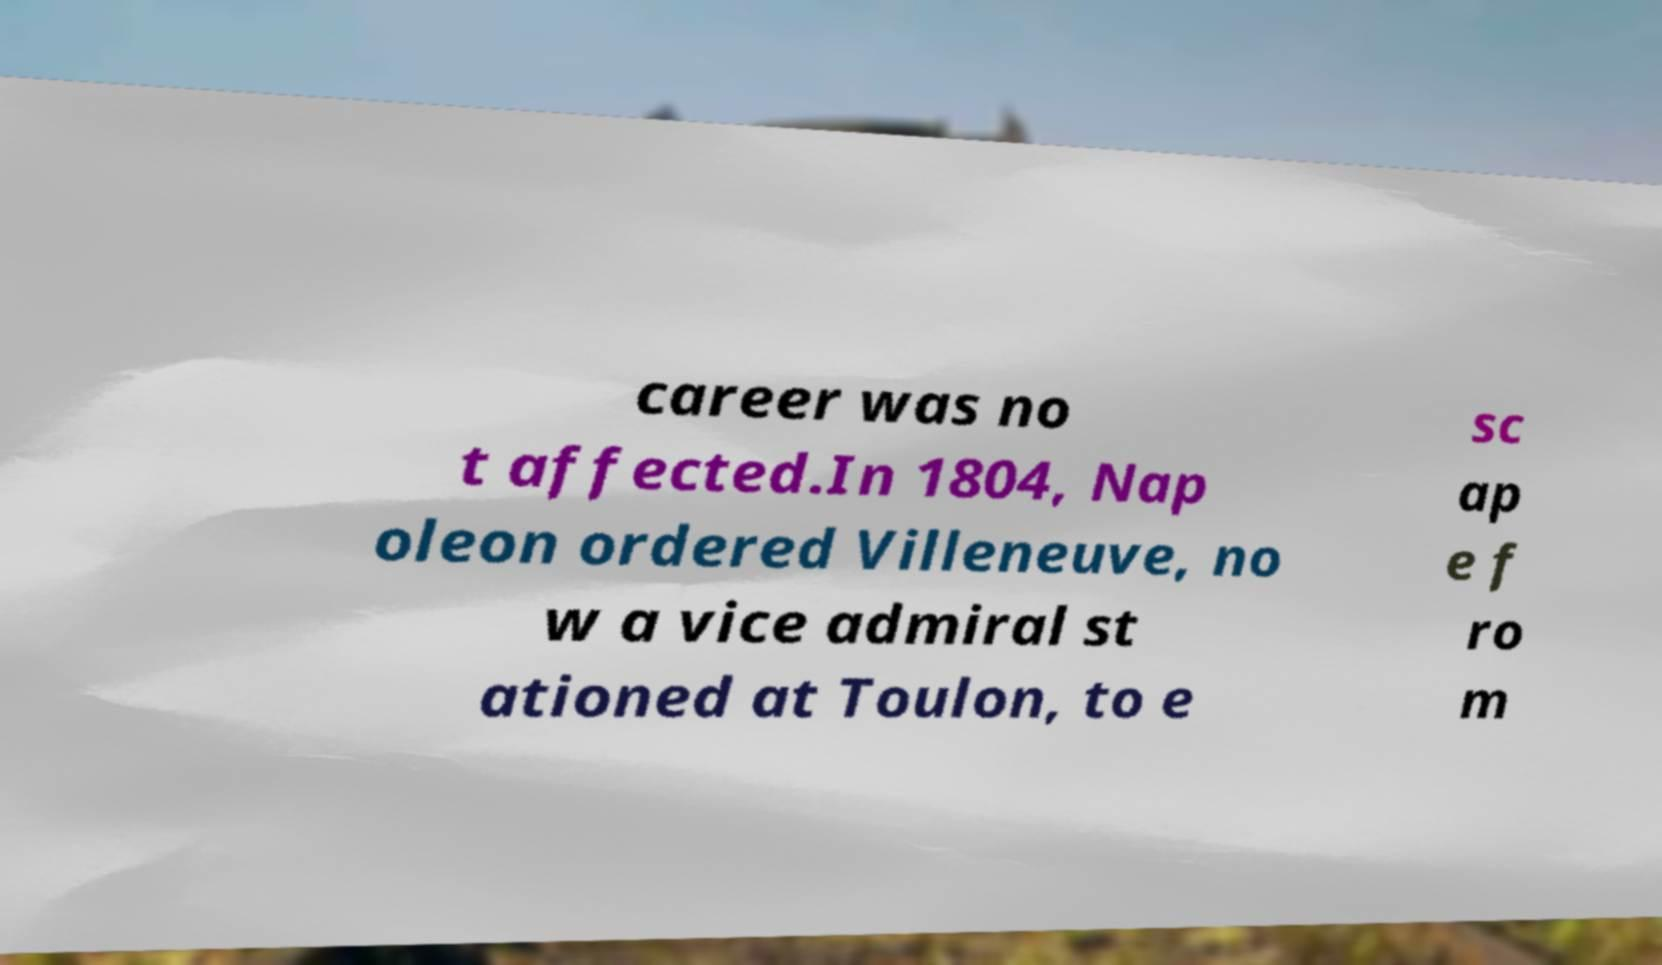What messages or text are displayed in this image? I need them in a readable, typed format. career was no t affected.In 1804, Nap oleon ordered Villeneuve, no w a vice admiral st ationed at Toulon, to e sc ap e f ro m 